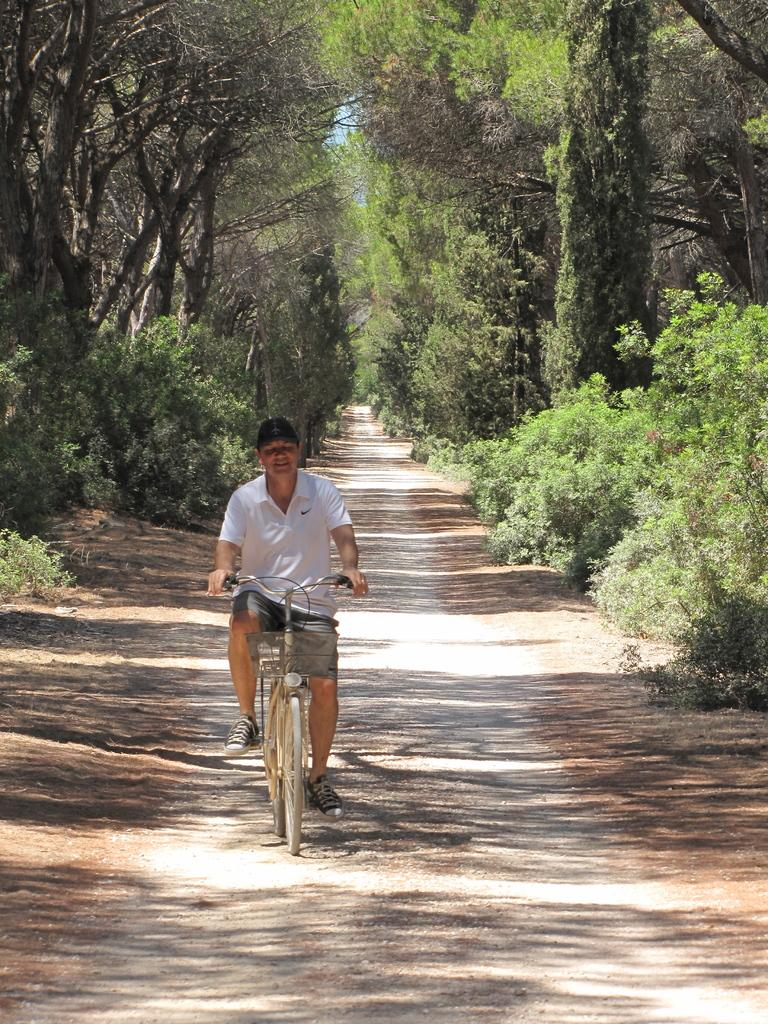What is the man in the image doing? The man is riding a bicycle in the image. What is the man's facial expression in the image? The man is smiling in the image. What can be seen in the background of the image? There are trees in the background of the image. What type of protest is the man participating in while riding the bicycle in the image? There is no protest present in the image; the man is simply riding a bicycle and smiling. 